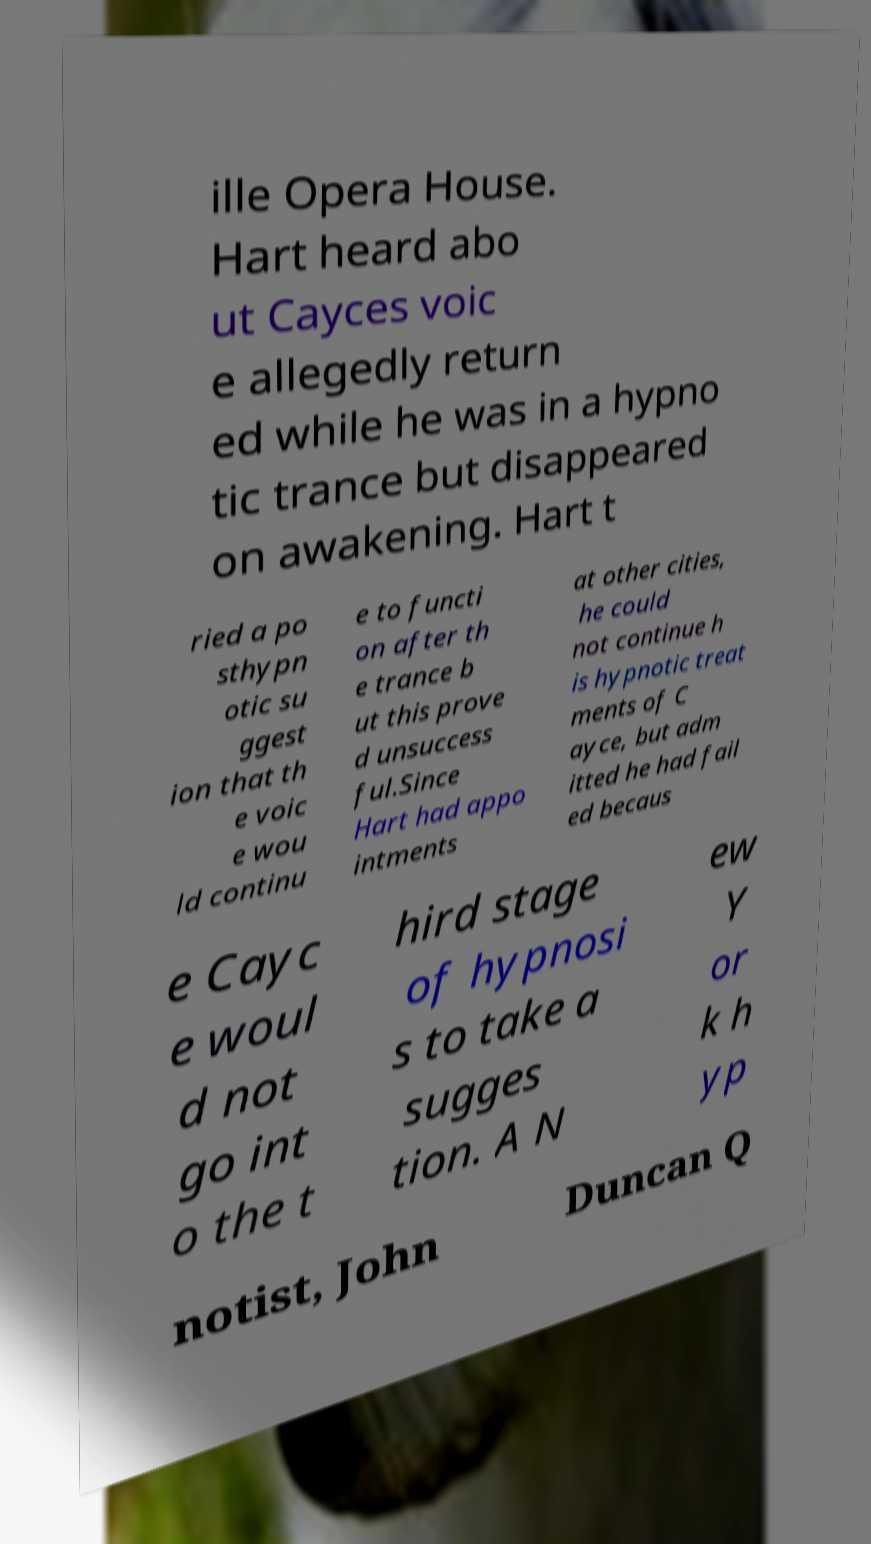Can you read and provide the text displayed in the image?This photo seems to have some interesting text. Can you extract and type it out for me? ille Opera House. Hart heard abo ut Cayces voic e allegedly return ed while he was in a hypno tic trance but disappeared on awakening. Hart t ried a po sthypn otic su ggest ion that th e voic e wou ld continu e to functi on after th e trance b ut this prove d unsuccess ful.Since Hart had appo intments at other cities, he could not continue h is hypnotic treat ments of C ayce, but adm itted he had fail ed becaus e Cayc e woul d not go int o the t hird stage of hypnosi s to take a sugges tion. A N ew Y or k h yp notist, John Duncan Q 